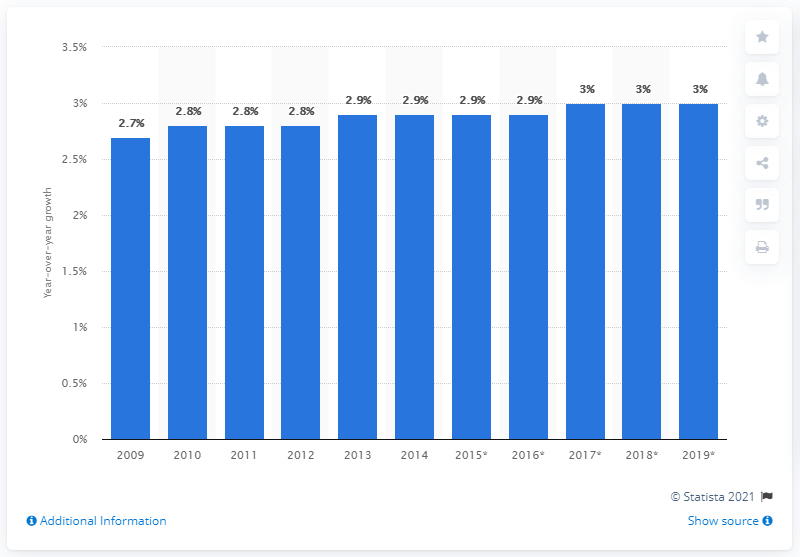Highlight a few significant elements in this photo. The market value of take-home ice cream in Canada in 2009 was approximately CAD 2.7 billion. In 2014, the market value of take-home ice cream increased by 2.7 percent. 